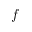Convert formula to latex. <formula><loc_0><loc_0><loc_500><loc_500>f</formula> 